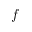Convert formula to latex. <formula><loc_0><loc_0><loc_500><loc_500>f</formula> 